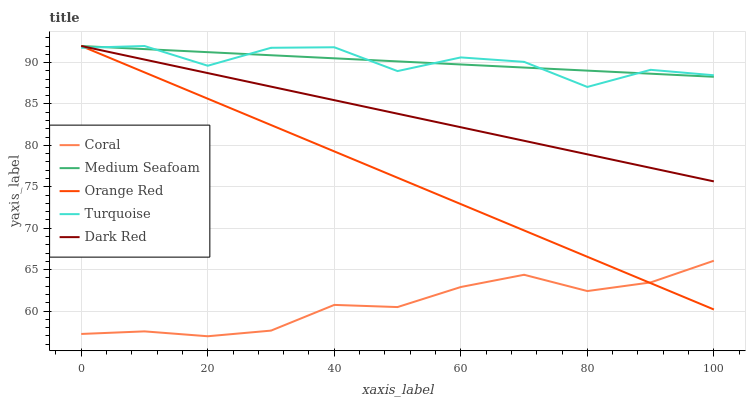Does Coral have the minimum area under the curve?
Answer yes or no. Yes. Does Medium Seafoam have the maximum area under the curve?
Answer yes or no. Yes. Does Turquoise have the minimum area under the curve?
Answer yes or no. No. Does Turquoise have the maximum area under the curve?
Answer yes or no. No. Is Dark Red the smoothest?
Answer yes or no. Yes. Is Turquoise the roughest?
Answer yes or no. Yes. Is Coral the smoothest?
Answer yes or no. No. Is Coral the roughest?
Answer yes or no. No. Does Coral have the lowest value?
Answer yes or no. Yes. Does Turquoise have the lowest value?
Answer yes or no. No. Does Orange Red have the highest value?
Answer yes or no. Yes. Does Coral have the highest value?
Answer yes or no. No. Is Coral less than Medium Seafoam?
Answer yes or no. Yes. Is Turquoise greater than Coral?
Answer yes or no. Yes. Does Medium Seafoam intersect Turquoise?
Answer yes or no. Yes. Is Medium Seafoam less than Turquoise?
Answer yes or no. No. Is Medium Seafoam greater than Turquoise?
Answer yes or no. No. Does Coral intersect Medium Seafoam?
Answer yes or no. No. 